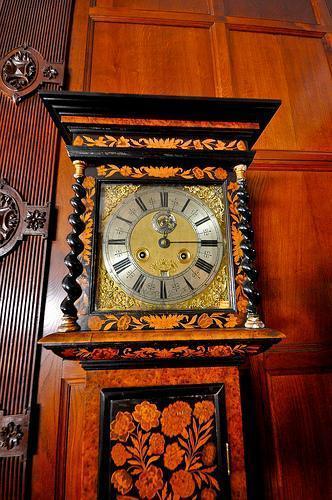How many clocks are in the photo?
Give a very brief answer. 1. 